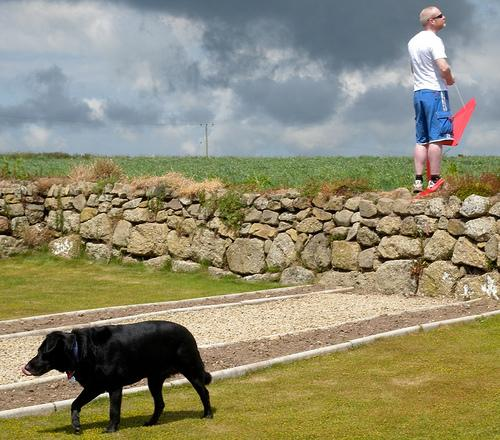What is the flag made of? Please explain your reasoning. plastic. The man is holding a flag made of light red plastic. 